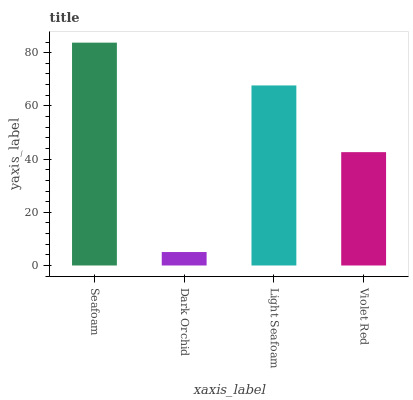Is Dark Orchid the minimum?
Answer yes or no. Yes. Is Seafoam the maximum?
Answer yes or no. Yes. Is Light Seafoam the minimum?
Answer yes or no. No. Is Light Seafoam the maximum?
Answer yes or no. No. Is Light Seafoam greater than Dark Orchid?
Answer yes or no. Yes. Is Dark Orchid less than Light Seafoam?
Answer yes or no. Yes. Is Dark Orchid greater than Light Seafoam?
Answer yes or no. No. Is Light Seafoam less than Dark Orchid?
Answer yes or no. No. Is Light Seafoam the high median?
Answer yes or no. Yes. Is Violet Red the low median?
Answer yes or no. Yes. Is Dark Orchid the high median?
Answer yes or no. No. Is Light Seafoam the low median?
Answer yes or no. No. 